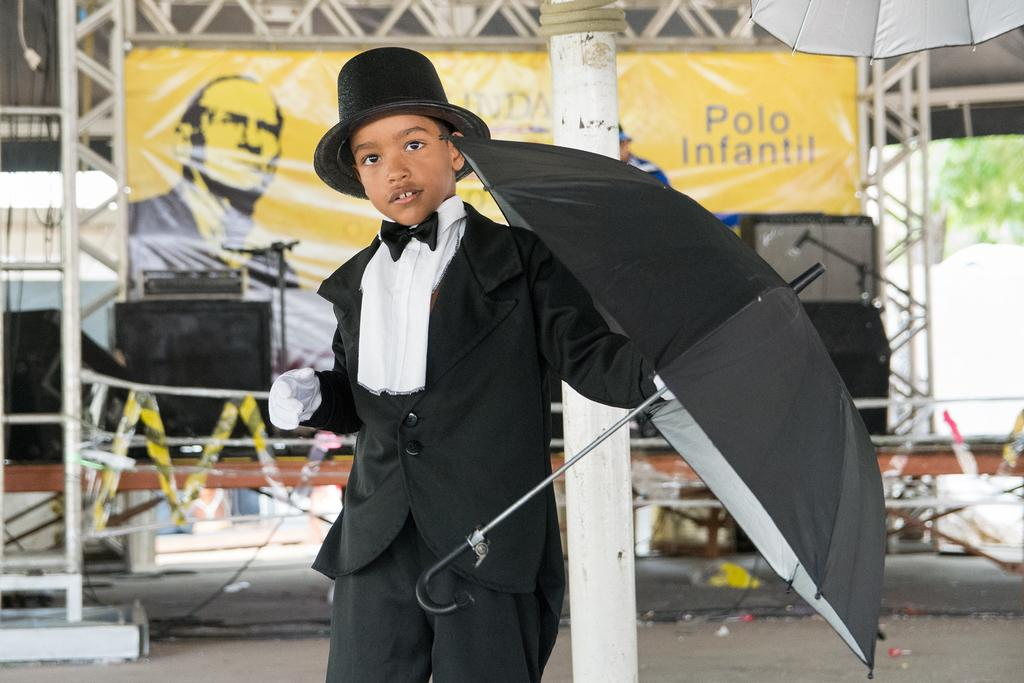Who is present in the image? There is a boy in the image. What is the boy wearing on his head? The boy is wearing a hat. What is the boy holding in the image? The boy is holding an umbrella. What can be seen in the background of the image? There is a hoarding and speakers in the background of the image. What type of cactus can be seen growing near the boy in the image? There is no cactus present in the image. What kind of bait is the boy using to catch fish in the image? There is no fishing or bait visible in the image. 